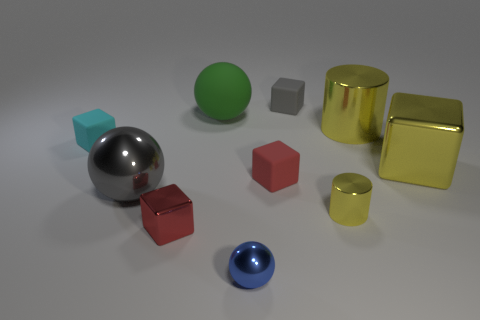Subtract all green cubes. Subtract all purple cylinders. How many cubes are left? 5 Subtract all balls. How many objects are left? 7 Add 7 cyan blocks. How many cyan blocks are left? 8 Add 7 big blue rubber spheres. How many big blue rubber spheres exist? 7 Subtract 0 gray cylinders. How many objects are left? 10 Subtract all tiny red rubber blocks. Subtract all small red metallic blocks. How many objects are left? 8 